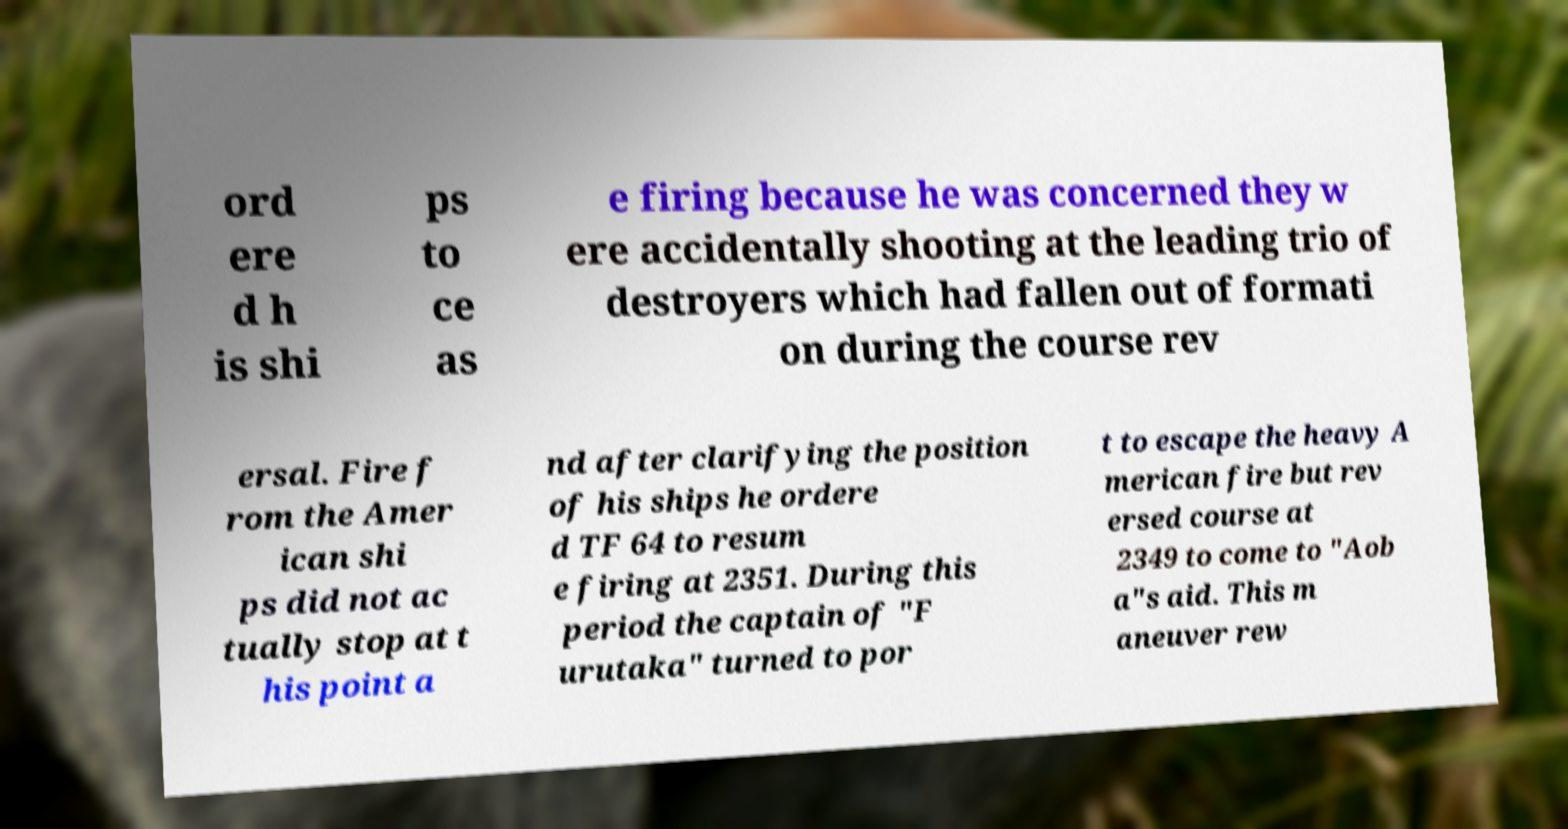Can you read and provide the text displayed in the image?This photo seems to have some interesting text. Can you extract and type it out for me? ord ere d h is shi ps to ce as e firing because he was concerned they w ere accidentally shooting at the leading trio of destroyers which had fallen out of formati on during the course rev ersal. Fire f rom the Amer ican shi ps did not ac tually stop at t his point a nd after clarifying the position of his ships he ordere d TF 64 to resum e firing at 2351. During this period the captain of "F urutaka" turned to por t to escape the heavy A merican fire but rev ersed course at 2349 to come to "Aob a"s aid. This m aneuver rew 